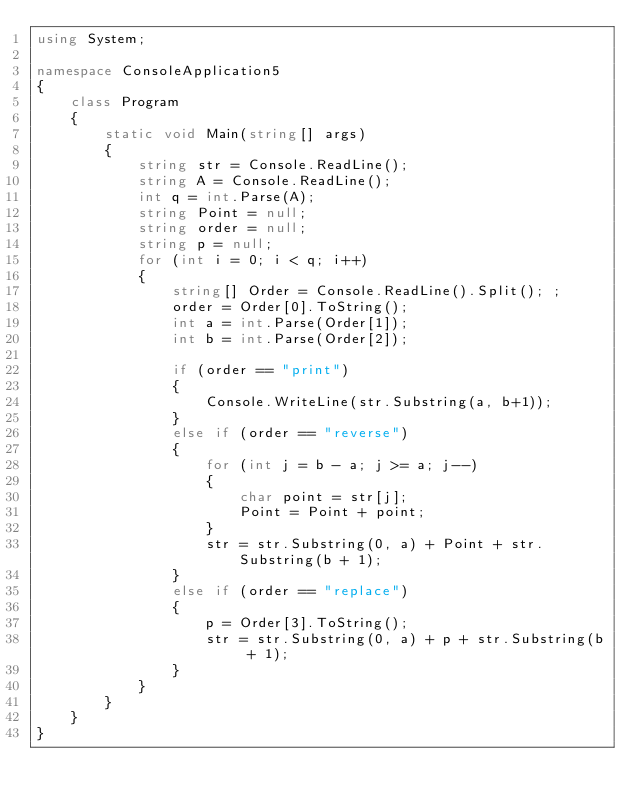<code> <loc_0><loc_0><loc_500><loc_500><_C#_>using System;

namespace ConsoleApplication5
{
    class Program
    {
        static void Main(string[] args)
        {
            string str = Console.ReadLine();
            string A = Console.ReadLine();
            int q = int.Parse(A);
            string Point = null;
            string order = null;
            string p = null;
            for (int i = 0; i < q; i++)
            {
                string[] Order = Console.ReadLine().Split(); ;
                order = Order[0].ToString();
                int a = int.Parse(Order[1]);
                int b = int.Parse(Order[2]);
                
                if (order == "print")
                {
                    Console.WriteLine(str.Substring(a, b+1));
                }
                else if (order == "reverse")
                {
                    for (int j = b - a; j >= a; j--)
                    {
                        char point = str[j];
                        Point = Point + point;
                    }
                    str = str.Substring(0, a) + Point + str.Substring(b + 1);
                }
                else if (order == "replace")
                {
                    p = Order[3].ToString();
                    str = str.Substring(0, a) + p + str.Substring(b + 1);
                }
            }
        }
    }
}</code> 